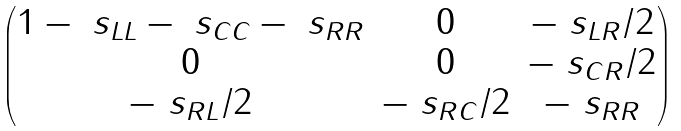<formula> <loc_0><loc_0><loc_500><loc_500>\begin{pmatrix} 1 - \ s _ { L L } - \ s _ { C C } - \ s _ { R R } & 0 & - \ s _ { L R } / 2 \\ 0 & 0 & - \ s _ { C R } / 2 \\ - \ s _ { R L } / 2 & - \ s _ { R C } / 2 & - \ s _ { R R } \end{pmatrix}</formula> 